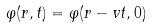Convert formula to latex. <formula><loc_0><loc_0><loc_500><loc_500>\varphi ( { r } , t ) = \varphi ( { r } - { v } t , 0 )</formula> 